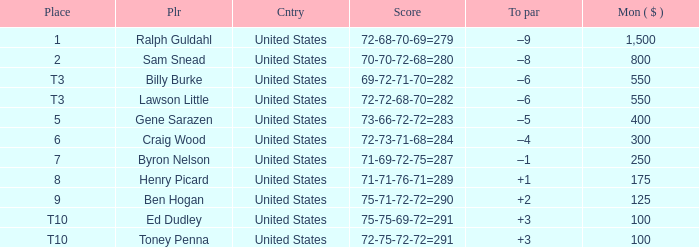Which to par has a prize less than $800? –8. Parse the table in full. {'header': ['Place', 'Plr', 'Cntry', 'Score', 'To par', 'Mon ( $ )'], 'rows': [['1', 'Ralph Guldahl', 'United States', '72-68-70-69=279', '–9', '1,500'], ['2', 'Sam Snead', 'United States', '70-70-72-68=280', '–8', '800'], ['T3', 'Billy Burke', 'United States', '69-72-71-70=282', '–6', '550'], ['T3', 'Lawson Little', 'United States', '72-72-68-70=282', '–6', '550'], ['5', 'Gene Sarazen', 'United States', '73-66-72-72=283', '–5', '400'], ['6', 'Craig Wood', 'United States', '72-73-71-68=284', '–4', '300'], ['7', 'Byron Nelson', 'United States', '71-69-72-75=287', '–1', '250'], ['8', 'Henry Picard', 'United States', '71-71-76-71=289', '+1', '175'], ['9', 'Ben Hogan', 'United States', '75-71-72-72=290', '+2', '125'], ['T10', 'Ed Dudley', 'United States', '75-75-69-72=291', '+3', '100'], ['T10', 'Toney Penna', 'United States', '72-75-72-72=291', '+3', '100']]} 